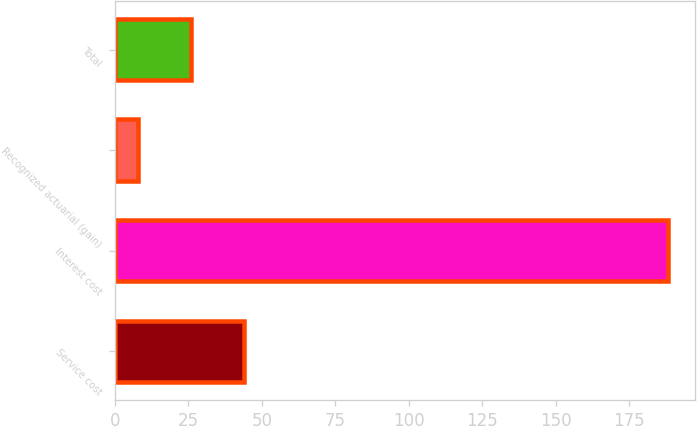Convert chart to OTSL. <chart><loc_0><loc_0><loc_500><loc_500><bar_chart><fcel>Service cost<fcel>Interest cost<fcel>Recognized actuarial (gain)<fcel>Total<nl><fcel>44<fcel>188<fcel>8<fcel>26<nl></chart> 